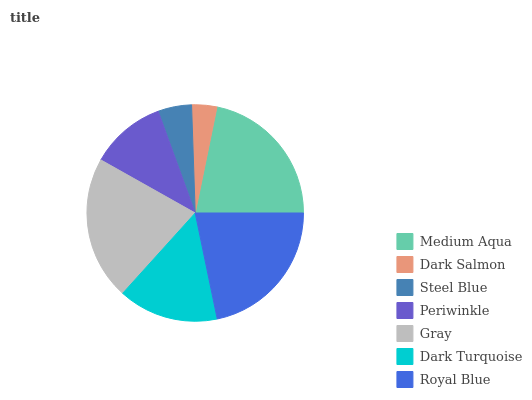Is Dark Salmon the minimum?
Answer yes or no. Yes. Is Medium Aqua the maximum?
Answer yes or no. Yes. Is Steel Blue the minimum?
Answer yes or no. No. Is Steel Blue the maximum?
Answer yes or no. No. Is Steel Blue greater than Dark Salmon?
Answer yes or no. Yes. Is Dark Salmon less than Steel Blue?
Answer yes or no. Yes. Is Dark Salmon greater than Steel Blue?
Answer yes or no. No. Is Steel Blue less than Dark Salmon?
Answer yes or no. No. Is Dark Turquoise the high median?
Answer yes or no. Yes. Is Dark Turquoise the low median?
Answer yes or no. Yes. Is Royal Blue the high median?
Answer yes or no. No. Is Gray the low median?
Answer yes or no. No. 